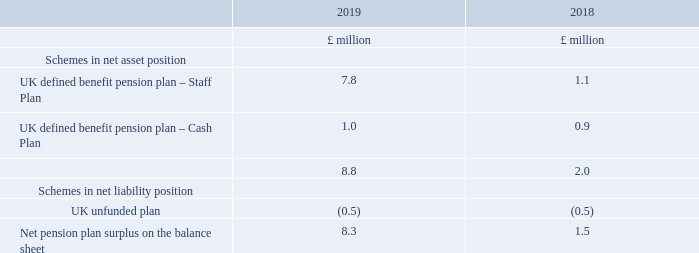Ii) amounts in the financial statements
the assets and liabilities on the balance sheet are as follows:
3. pensions continued
what was the net pension plan surplus on the balance sheet in 2019?
answer scale should be: million. 8.3. What are the schemes comprising the assets and liabilities on the balance sheet in the table? Schemes in net asset position, schemes in net liability position. What are the plans under Schemes in net asset position? Uk defined benefit pension plan – staff plan, uk defined benefit pension plan – cash plan. In which year was the amount of UK defined benefit pension plan – Cash Plan larger? 1.0>0.9
Answer: 2019. What was the change in the net pension plan surplus on the balance sheet?
Answer scale should be: million. 8.3-1.5
Answer: 6.8. What was the percentage change in the net pension plan surplus on the balance sheet?
Answer scale should be: percent. (8.3-1.5)/1.5
Answer: 453.33. 